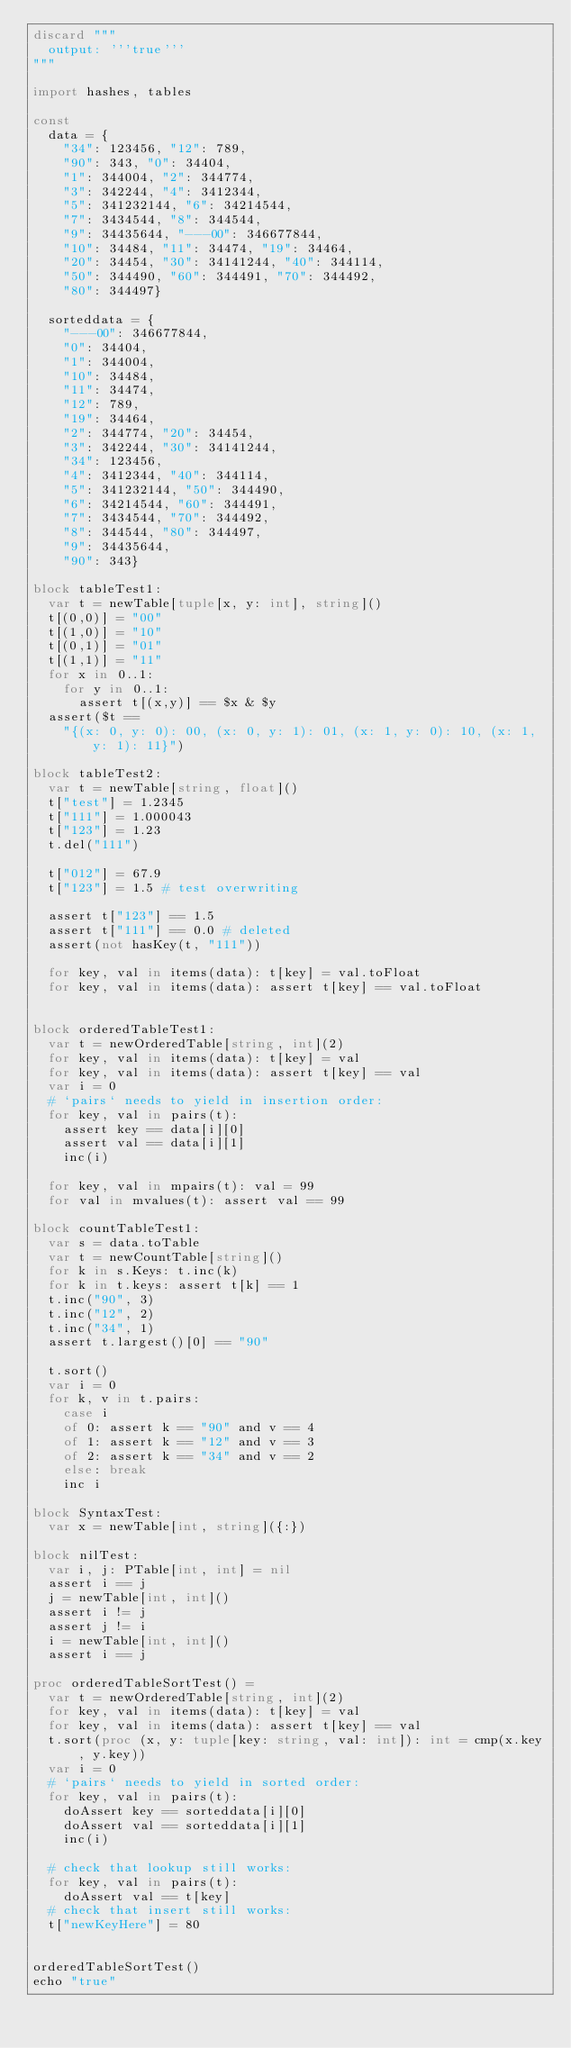<code> <loc_0><loc_0><loc_500><loc_500><_Nim_>discard """
  output: '''true'''
"""

import hashes, tables

const
  data = {
    "34": 123456, "12": 789,
    "90": 343, "0": 34404,
    "1": 344004, "2": 344774,
    "3": 342244, "4": 3412344,
    "5": 341232144, "6": 34214544,
    "7": 3434544, "8": 344544,
    "9": 34435644, "---00": 346677844,
    "10": 34484, "11": 34474, "19": 34464,
    "20": 34454, "30": 34141244, "40": 344114,
    "50": 344490, "60": 344491, "70": 344492,
    "80": 344497}

  sorteddata = {
    "---00": 346677844,
    "0": 34404,
    "1": 344004,
    "10": 34484, 
    "11": 34474,
    "12": 789,
    "19": 34464,
    "2": 344774, "20": 34454, 
    "3": 342244, "30": 34141244,
    "34": 123456,
    "4": 3412344, "40": 344114,
    "5": 341232144, "50": 344490, 
    "6": 34214544, "60": 344491,
    "7": 3434544, "70": 344492,
    "8": 344544, "80": 344497,
    "9": 34435644,
    "90": 343}

block tableTest1:
  var t = newTable[tuple[x, y: int], string]()
  t[(0,0)] = "00"
  t[(1,0)] = "10"
  t[(0,1)] = "01"
  t[(1,1)] = "11"
  for x in 0..1:
    for y in 0..1:
      assert t[(x,y)] == $x & $y
  assert($t == 
    "{(x: 0, y: 0): 00, (x: 0, y: 1): 01, (x: 1, y: 0): 10, (x: 1, y: 1): 11}")

block tableTest2:
  var t = newTable[string, float]()
  t["test"] = 1.2345
  t["111"] = 1.000043
  t["123"] = 1.23
  t.del("111")
  
  t["012"] = 67.9
  t["123"] = 1.5 # test overwriting
  
  assert t["123"] == 1.5
  assert t["111"] == 0.0 # deleted
  assert(not hasKey(t, "111"))
  
  for key, val in items(data): t[key] = val.toFloat
  for key, val in items(data): assert t[key] == val.toFloat
  

block orderedTableTest1:
  var t = newOrderedTable[string, int](2)
  for key, val in items(data): t[key] = val
  for key, val in items(data): assert t[key] == val
  var i = 0
  # `pairs` needs to yield in insertion order:
  for key, val in pairs(t):
    assert key == data[i][0]
    assert val == data[i][1]
    inc(i)

  for key, val in mpairs(t): val = 99
  for val in mvalues(t): assert val == 99

block countTableTest1:
  var s = data.toTable
  var t = newCountTable[string]()
  for k in s.Keys: t.inc(k)
  for k in t.keys: assert t[k] == 1
  t.inc("90", 3)
  t.inc("12", 2)
  t.inc("34", 1)
  assert t.largest()[0] == "90"

  t.sort()
  var i = 0
  for k, v in t.pairs:
    case i
    of 0: assert k == "90" and v == 4
    of 1: assert k == "12" and v == 3
    of 2: assert k == "34" and v == 2
    else: break
    inc i

block SyntaxTest:
  var x = newTable[int, string]({:})

block nilTest:
  var i, j: PTable[int, int] = nil
  assert i == j
  j = newTable[int, int]()
  assert i != j
  assert j != i
  i = newTable[int, int]()
  assert i == j

proc orderedTableSortTest() =
  var t = newOrderedTable[string, int](2)
  for key, val in items(data): t[key] = val
  for key, val in items(data): assert t[key] == val
  t.sort(proc (x, y: tuple[key: string, val: int]): int = cmp(x.key, y.key))
  var i = 0
  # `pairs` needs to yield in sorted order:
  for key, val in pairs(t):
    doAssert key == sorteddata[i][0]
    doAssert val == sorteddata[i][1]
    inc(i)

  # check that lookup still works:
  for key, val in pairs(t):
    doAssert val == t[key]
  # check that insert still works:
  t["newKeyHere"] = 80


orderedTableSortTest()
echo "true"

</code> 